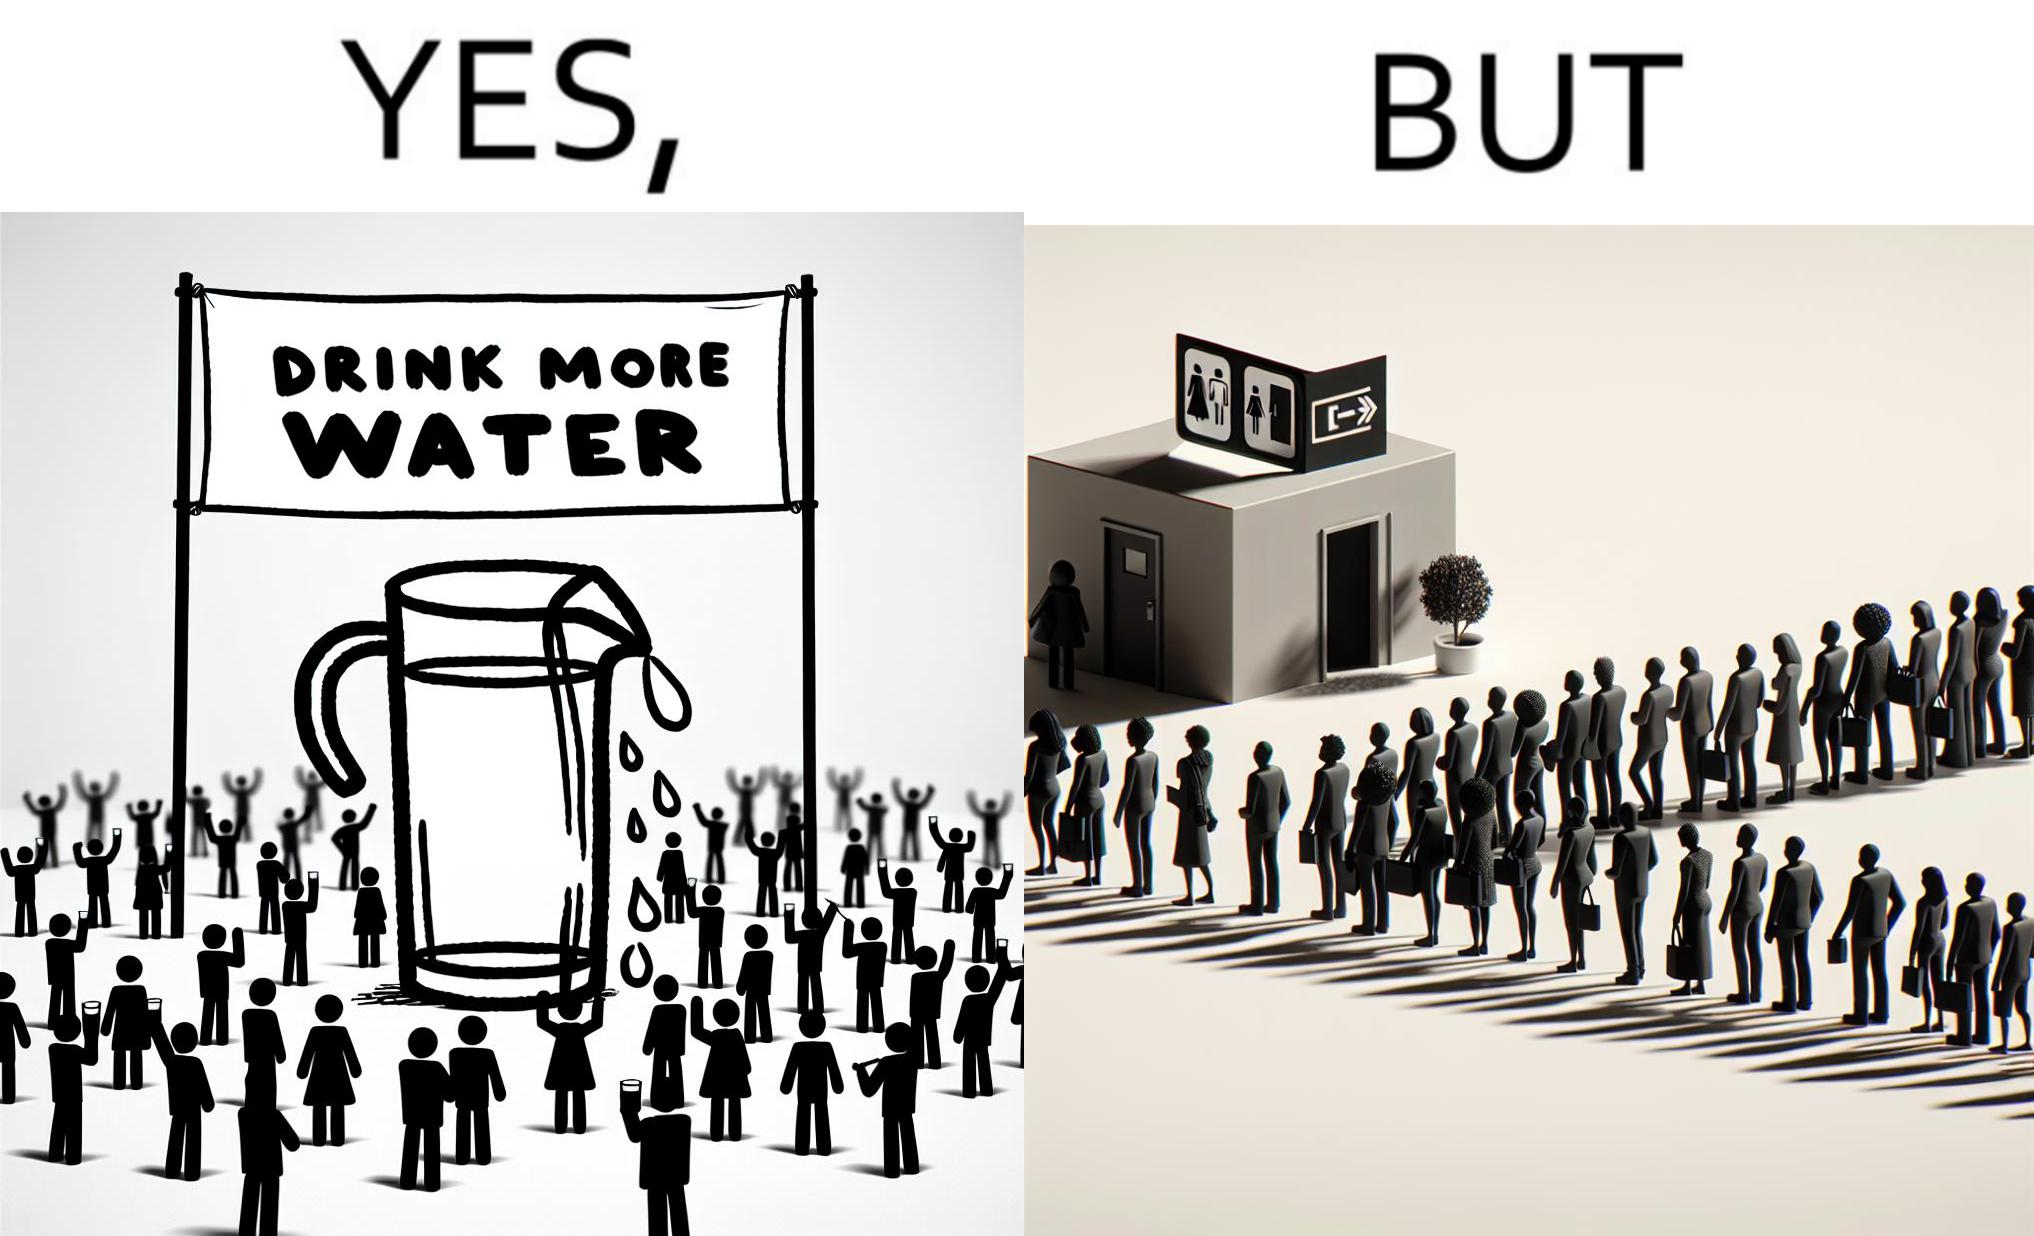Describe the content of this image. The image is ironical, as the message "Drink more water" is meant to improve health, but in turn, it would lead to longer queues in front of public toilets, leading to people holding urine for longer periods, in turn leading to deterioration in health. 